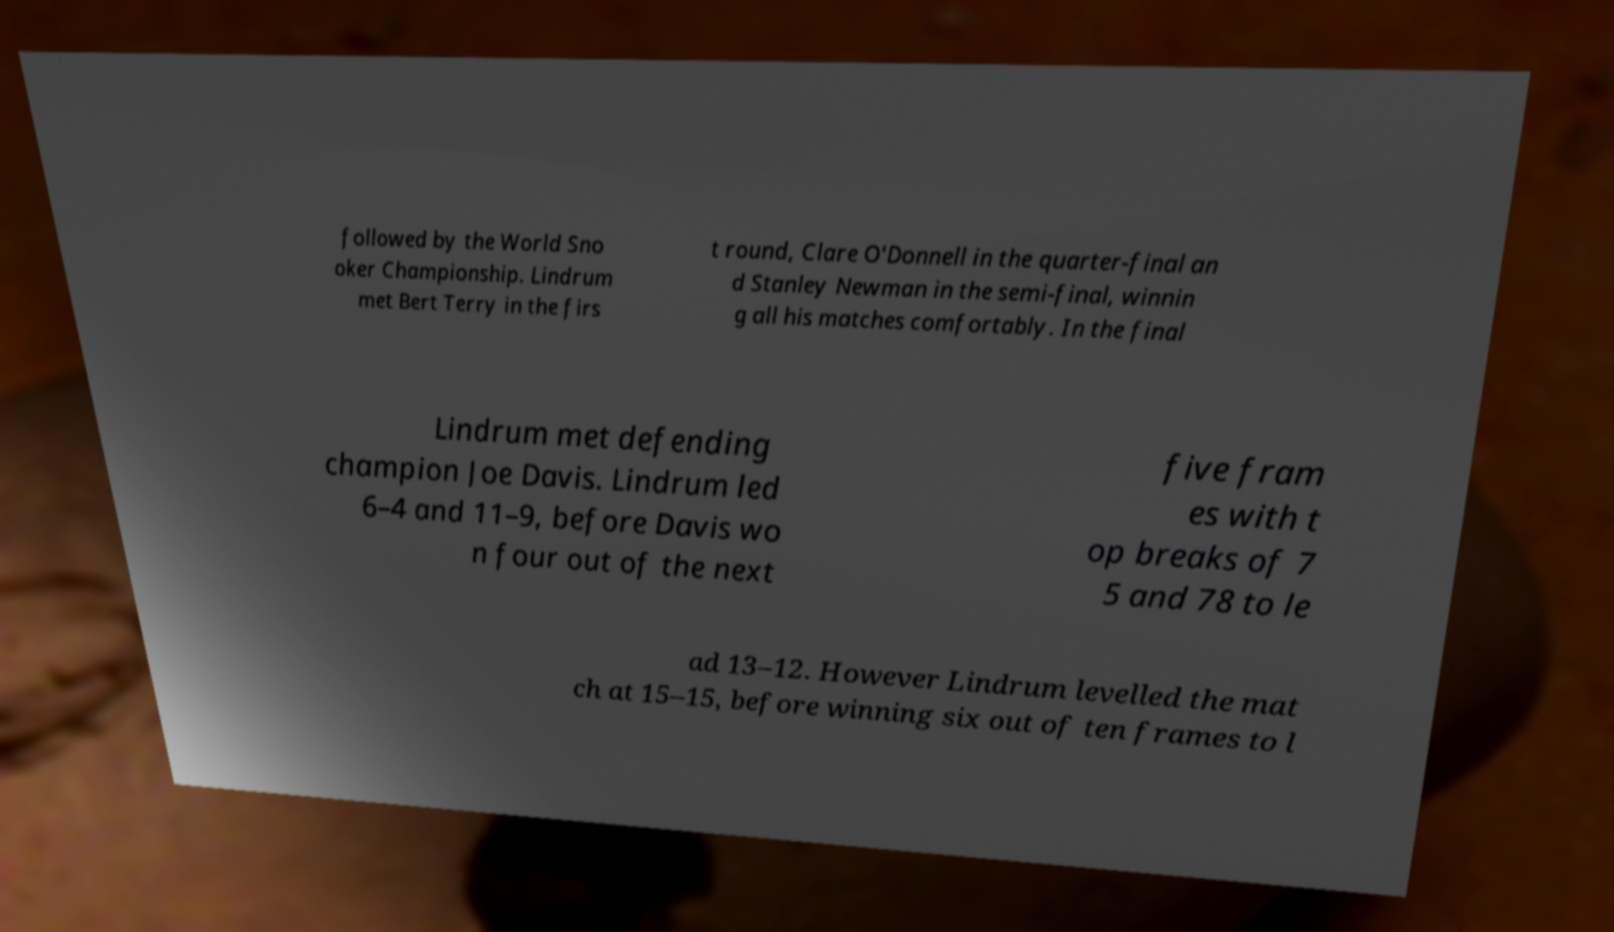For documentation purposes, I need the text within this image transcribed. Could you provide that? followed by the World Sno oker Championship. Lindrum met Bert Terry in the firs t round, Clare O'Donnell in the quarter-final an d Stanley Newman in the semi-final, winnin g all his matches comfortably. In the final Lindrum met defending champion Joe Davis. Lindrum led 6–4 and 11–9, before Davis wo n four out of the next five fram es with t op breaks of 7 5 and 78 to le ad 13–12. However Lindrum levelled the mat ch at 15–15, before winning six out of ten frames to l 